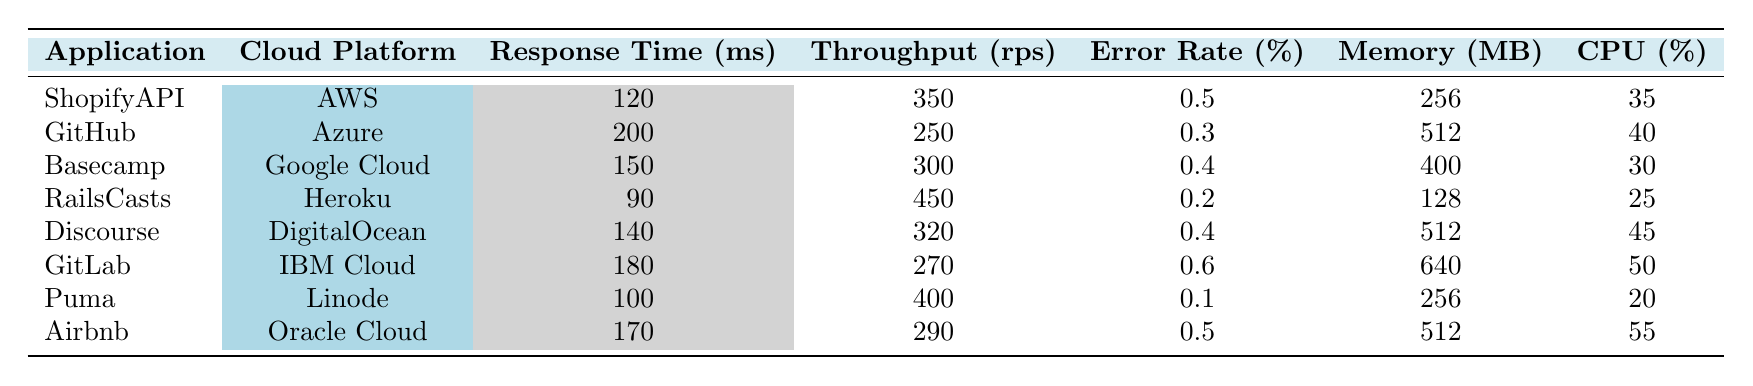What is the response time of the RailsCasts application? According to the table, the response time of the RailsCasts application is listed in milliseconds. It shows a value of 90 ms.
Answer: 90 ms Which application has the highest throughput? Looking at the "Throughput (rps)" column, the application with the highest value is RailsCasts at 450 requests per second.
Answer: RailsCasts What is the error rate percentage for GitLab? The error rate percentage for GitLab can be found in the "Error Rate (%)" column. It states that GitLab has an error rate of 0.6%.
Answer: 0.6% Which application has the lowest CPU usage? By checking the "CPU (%)" column, we observe that Puma has the lowest CPU usage at 20%.
Answer: Puma What is the average response time of all applications? First, we sum the response times: 120 + 200 + 150 + 90 + 140 + 180 + 100 + 170 = 1150. There are 8 applications, so the average response time is 1150 / 8 = 143.75 ms.
Answer: 143.75 ms How much memory does the Basecamp application use compared to the RailsCasts application? Basecamp uses 400 MB of memory, while RailsCasts uses 128 MB. The difference is calculated by subtracting 128 from 400, resulting in 272 MB more for Basecamp.
Answer: 272 MB Is the error rate for Discourse higher than that for GitHub? Discourse has an error rate of 0.4% and GitHub has an error rate of 0.3%. Since 0.4% is greater than 0.3%, the statement is true.
Answer: Yes What is the total CPU usage of all the applications on AWS? The only application on AWS is ShopifyAPI, which has a CPU usage of 35%. Therefore, the total CPU usage for AWS applications is 35%.
Answer: 35% Which cloud platform has the highest memory usage among the applications listed? The memory usage values are 256, 512, 400, 128, 512, 640, 256, and 512 MB. The highest value is 640 MB from GitLab on IBM Cloud.
Answer: IBM Cloud Is the throughput of the Airbnb application greater than that of GitLab? The throughput for Airbnb is 290 rps, while for GitLab, it is 270 rps. Since 290 is greater than 270, the statement is true.
Answer: Yes 